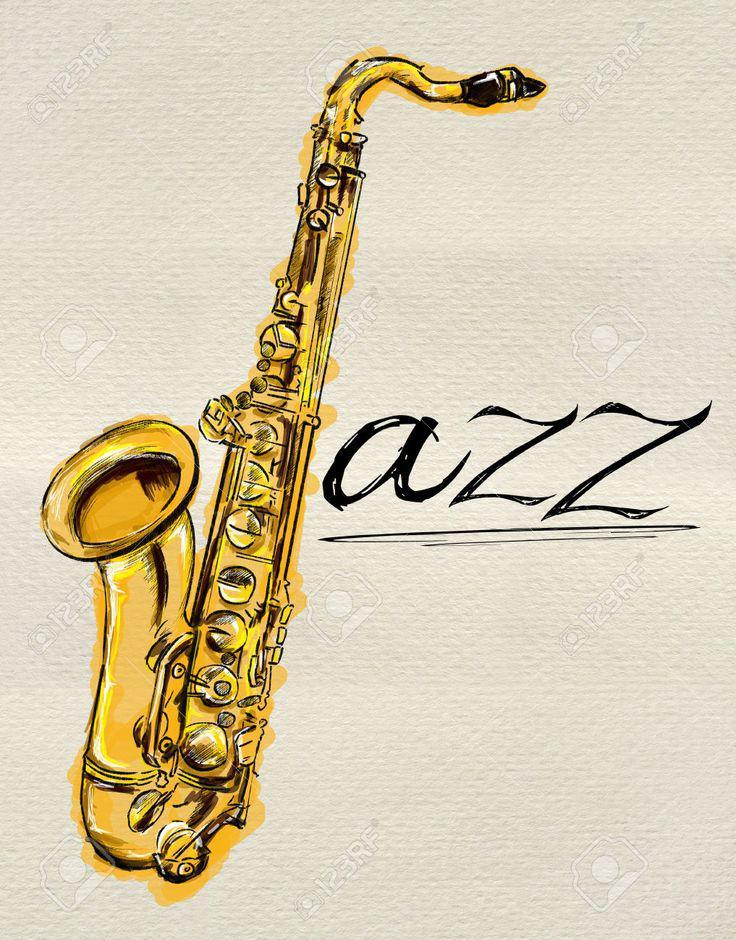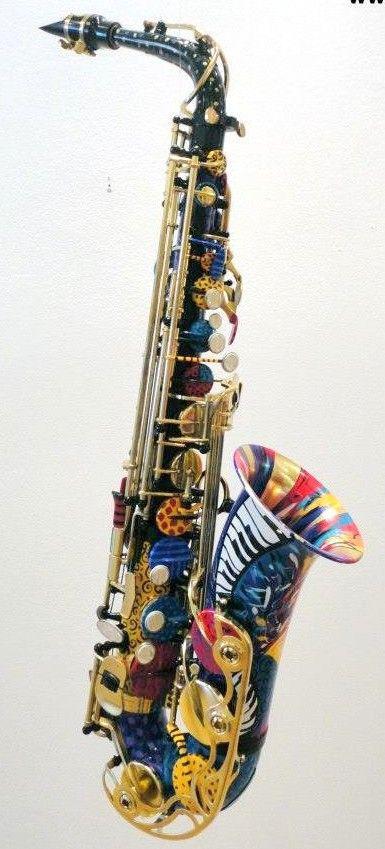The first image is the image on the left, the second image is the image on the right. Assess this claim about the two images: "In at least one image there is a single saxophone surrounded by purple special dots.". Correct or not? Answer yes or no. No. 